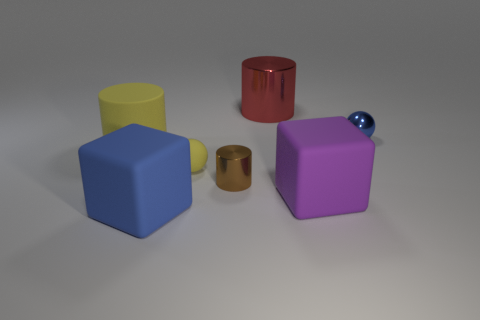Are there any purple cubes that have the same material as the yellow cylinder?
Keep it short and to the point. Yes. What number of small purple rubber objects have the same shape as the brown metallic thing?
Give a very brief answer. 0. What is the shape of the yellow object that is right of the large rubber object in front of the large cube to the right of the large metal object?
Provide a succinct answer. Sphere. There is a big thing that is both right of the tiny brown shiny object and on the left side of the large purple thing; what material is it?
Keep it short and to the point. Metal. Does the block left of the rubber ball have the same size as the tiny metal cylinder?
Your answer should be very brief. No. Are there any other things that are the same size as the matte ball?
Provide a succinct answer. Yes. Are there more cubes that are behind the yellow cylinder than blue cubes behind the large red metallic cylinder?
Provide a succinct answer. No. The large rubber thing that is right of the large rubber thing that is in front of the large cube to the right of the red metal cylinder is what color?
Offer a terse response. Purple. Does the metallic object in front of the big yellow matte object have the same color as the rubber cylinder?
Offer a terse response. No. What number of other things are there of the same color as the large metallic cylinder?
Your answer should be compact. 0. 